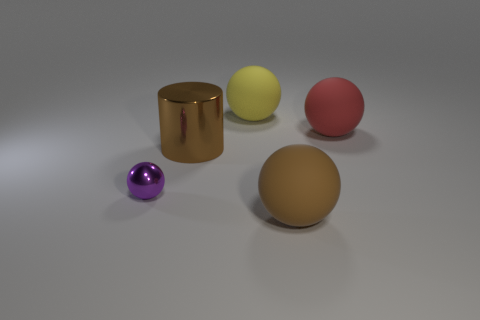There is a metallic thing that is the same shape as the large red rubber thing; what is its size?
Your response must be concise. Small. There is a large rubber sphere right of the rubber object in front of the red matte ball; what number of rubber things are on the left side of it?
Give a very brief answer. 2. Are there the same number of large brown things behind the brown ball and brown cylinders?
Keep it short and to the point. Yes. How many cubes are metallic objects or yellow matte objects?
Give a very brief answer. 0. Do the large metal object and the shiny sphere have the same color?
Ensure brevity in your answer.  No. Is the number of big yellow matte things that are in front of the large brown metal thing the same as the number of large yellow spheres in front of the red sphere?
Provide a short and direct response. Yes. What is the color of the small sphere?
Your answer should be compact. Purple. How many objects are either objects on the left side of the large cylinder or matte things?
Make the answer very short. 4. There is a brown object that is behind the brown sphere; is its size the same as the matte ball that is in front of the purple shiny sphere?
Give a very brief answer. Yes. Is there any other thing that is the same material as the brown cylinder?
Ensure brevity in your answer.  Yes. 